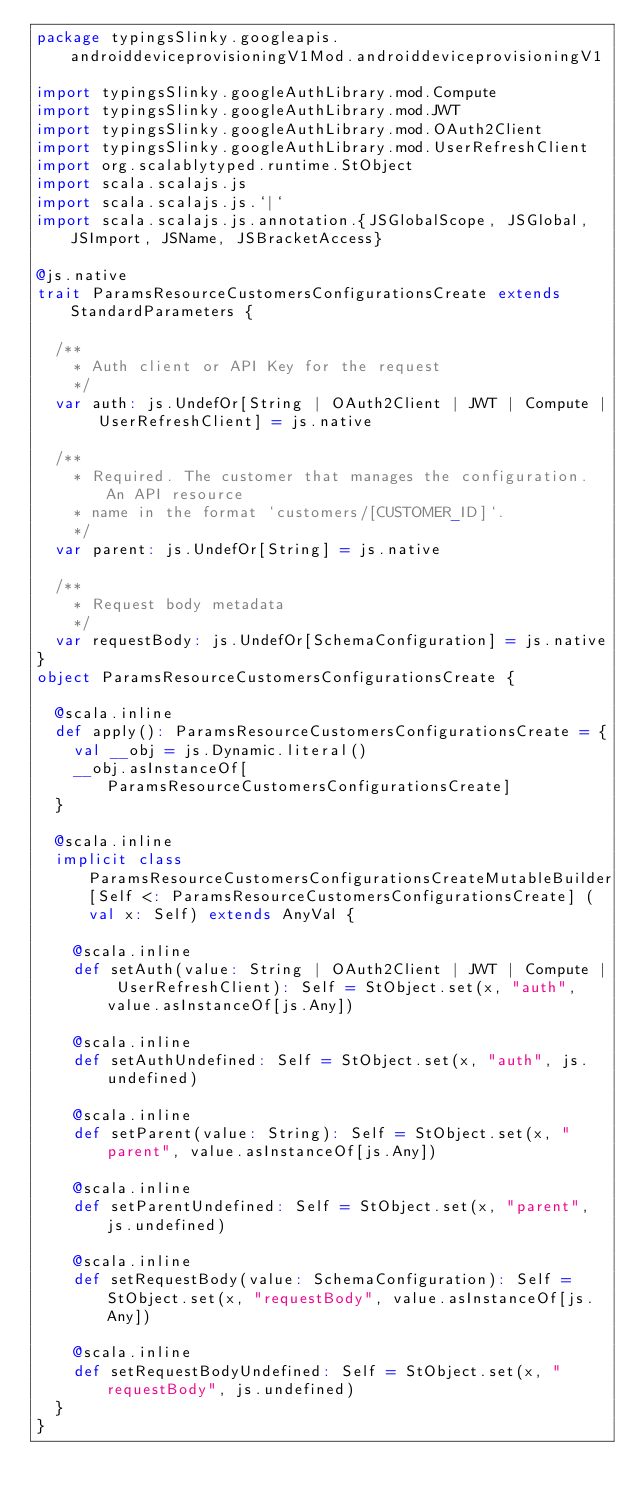Convert code to text. <code><loc_0><loc_0><loc_500><loc_500><_Scala_>package typingsSlinky.googleapis.androiddeviceprovisioningV1Mod.androiddeviceprovisioningV1

import typingsSlinky.googleAuthLibrary.mod.Compute
import typingsSlinky.googleAuthLibrary.mod.JWT
import typingsSlinky.googleAuthLibrary.mod.OAuth2Client
import typingsSlinky.googleAuthLibrary.mod.UserRefreshClient
import org.scalablytyped.runtime.StObject
import scala.scalajs.js
import scala.scalajs.js.`|`
import scala.scalajs.js.annotation.{JSGlobalScope, JSGlobal, JSImport, JSName, JSBracketAccess}

@js.native
trait ParamsResourceCustomersConfigurationsCreate extends StandardParameters {
  
  /**
    * Auth client or API Key for the request
    */
  var auth: js.UndefOr[String | OAuth2Client | JWT | Compute | UserRefreshClient] = js.native
  
  /**
    * Required. The customer that manages the configuration. An API resource
    * name in the format `customers/[CUSTOMER_ID]`.
    */
  var parent: js.UndefOr[String] = js.native
  
  /**
    * Request body metadata
    */
  var requestBody: js.UndefOr[SchemaConfiguration] = js.native
}
object ParamsResourceCustomersConfigurationsCreate {
  
  @scala.inline
  def apply(): ParamsResourceCustomersConfigurationsCreate = {
    val __obj = js.Dynamic.literal()
    __obj.asInstanceOf[ParamsResourceCustomersConfigurationsCreate]
  }
  
  @scala.inline
  implicit class ParamsResourceCustomersConfigurationsCreateMutableBuilder[Self <: ParamsResourceCustomersConfigurationsCreate] (val x: Self) extends AnyVal {
    
    @scala.inline
    def setAuth(value: String | OAuth2Client | JWT | Compute | UserRefreshClient): Self = StObject.set(x, "auth", value.asInstanceOf[js.Any])
    
    @scala.inline
    def setAuthUndefined: Self = StObject.set(x, "auth", js.undefined)
    
    @scala.inline
    def setParent(value: String): Self = StObject.set(x, "parent", value.asInstanceOf[js.Any])
    
    @scala.inline
    def setParentUndefined: Self = StObject.set(x, "parent", js.undefined)
    
    @scala.inline
    def setRequestBody(value: SchemaConfiguration): Self = StObject.set(x, "requestBody", value.asInstanceOf[js.Any])
    
    @scala.inline
    def setRequestBodyUndefined: Self = StObject.set(x, "requestBody", js.undefined)
  }
}
</code> 